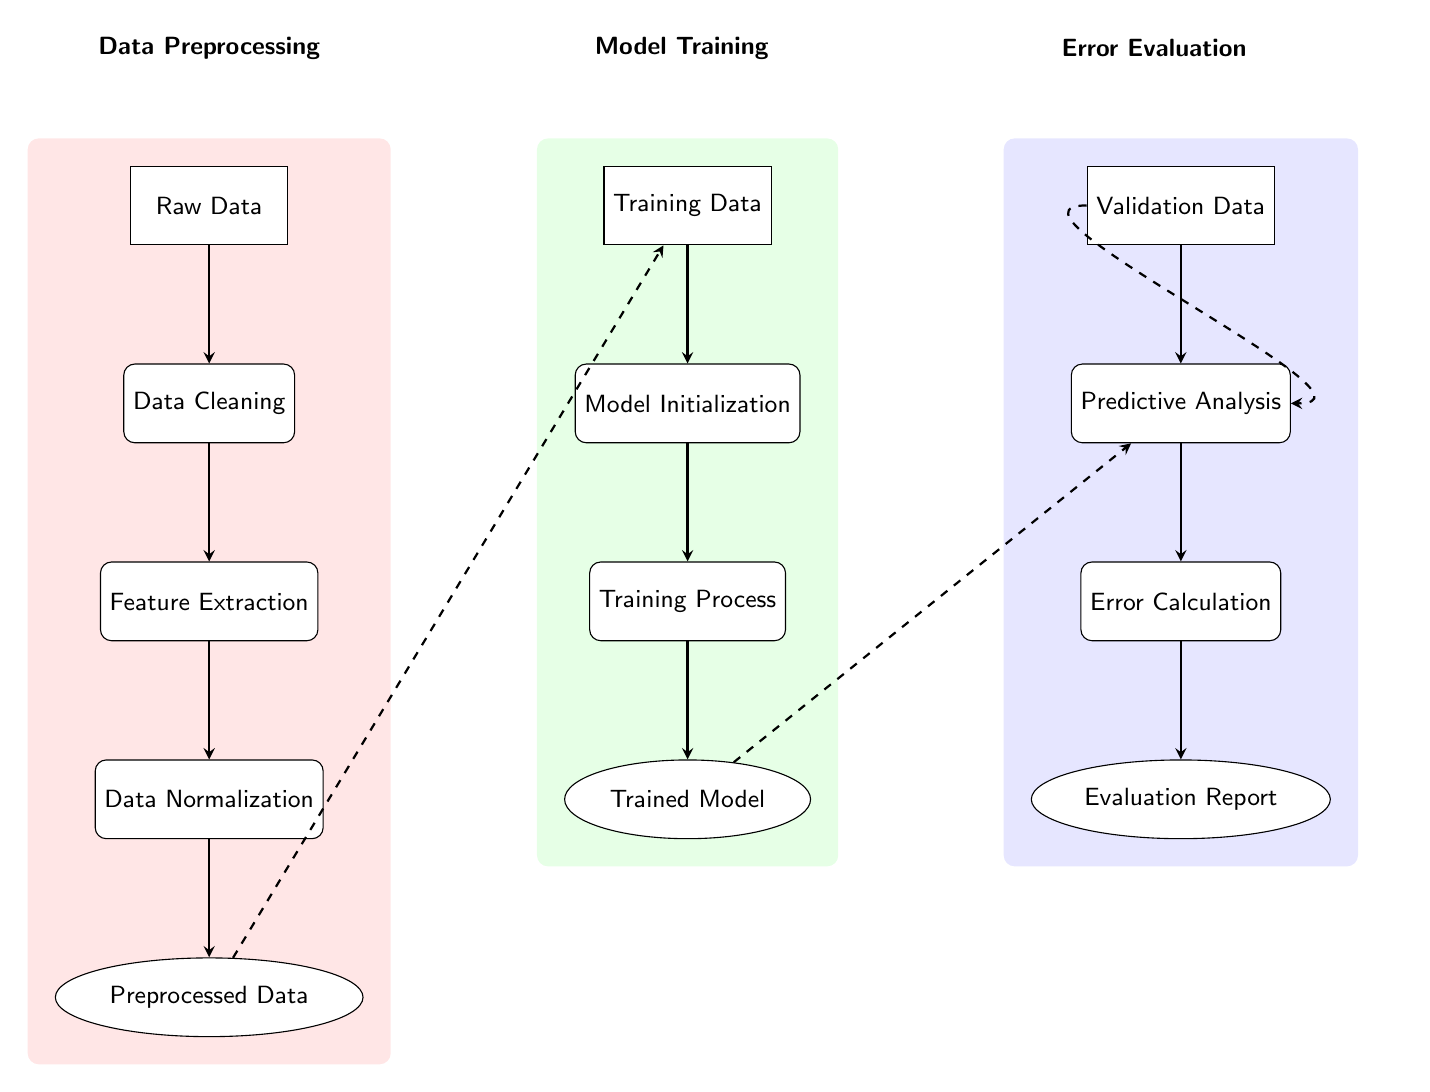What are the three main layers of the diagram? The diagram consists of three layers: Data Preprocessing, Model Training, and Error Evaluation, each representing a distinct stage in the machine learning pipeline.
Answer: Data Preprocessing, Model Training, Error Evaluation What is the output of the Data Preprocessing layer? The final output of the Data Preprocessing layer, which is below the Data Normalization process, is Preprocessed Data, indicating that the raw data has been transformed into a usable format for the next stage.
Answer: Preprocessed Data How many processes are in the Model Training layer? In the Model Training layer, there are three processes: Model Initialization, Training Process, and the final output is the Trained Model, indicating there are three distinct steps involved in this layer.
Answer: 3 What type of connection is shown between the Preprocessed Data and the Training Data? The connection between Preprocessed Data and Training Data is a dashed arrow, indicating it is a non-linear or indirect relationship, showing that preprocessed data is used as input for training the model.
Answer: Dashed arrow In which layer is the Predictive Analysis process located? The Predictive Analysis process is located in the Error Evaluation layer, positioned below the input Validation Data, representing the stage where predictions are made based on the training model.
Answer: Error Evaluation What is the last step in the Error Evaluation layer? The last step in the Error Evaluation layer is the Evaluation Report, which is the output that provides insights into the performance of the predictive model after error calculation.
Answer: Evaluation Report Which process receives Validation Data as input? The Predictive Analysis process receives Validation Data as input, as indicated by the arrow pointing to it from the Validation Data node.
Answer: Predictive Analysis How many nodes are in the Data Preprocessing layer? The Data Preprocessing layer contains five nodes: Raw Data, Data Cleaning, Feature Extraction, Data Normalization, and Preprocessed Data, showcasing the stages involved in preprocessing the data.
Answer: 5 What does the Error Calculation process yield? The Error Calculation process yields the Evaluation Report as its output, indicating the result of the error evaluation done after predictive analysis.
Answer: Evaluation Report 